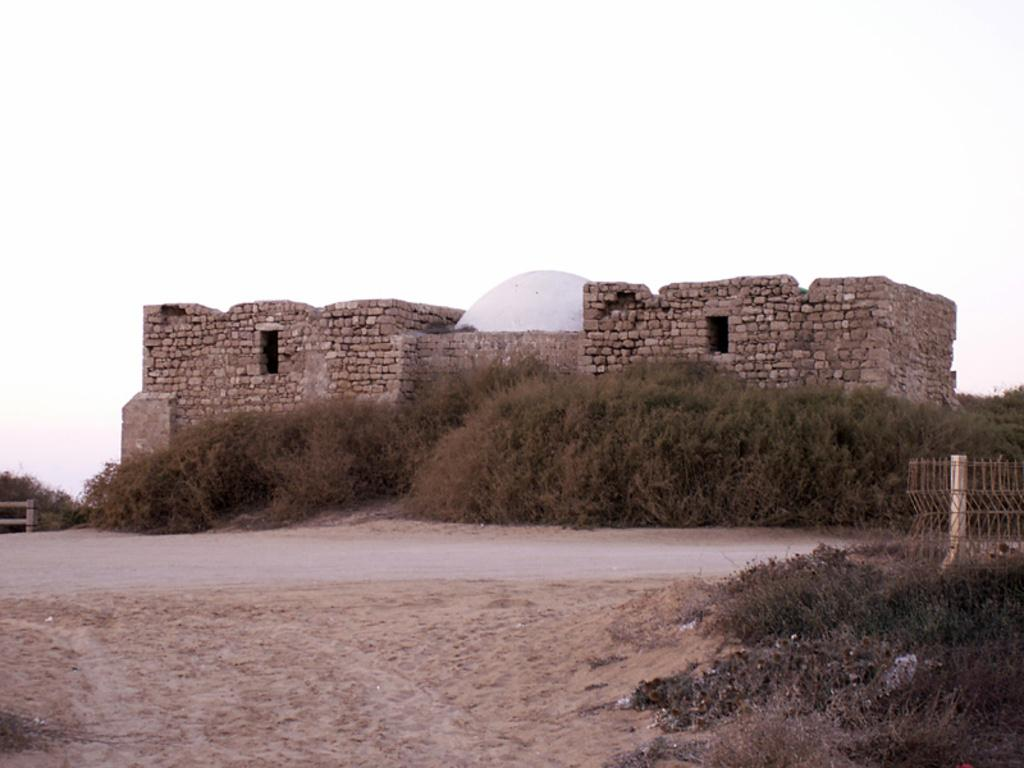What type of structure is visible in the image? There is a fort in the image. What can be seen in front of the fort? Plants are present in front of the fort. What type of pathway is visible in the image? There is a road in the image. What is visible above the fort and plants? The sky is visible in the image. What type of glove is being used by the beginner to play the board game in the image? There is no glove or board game present in the image. 